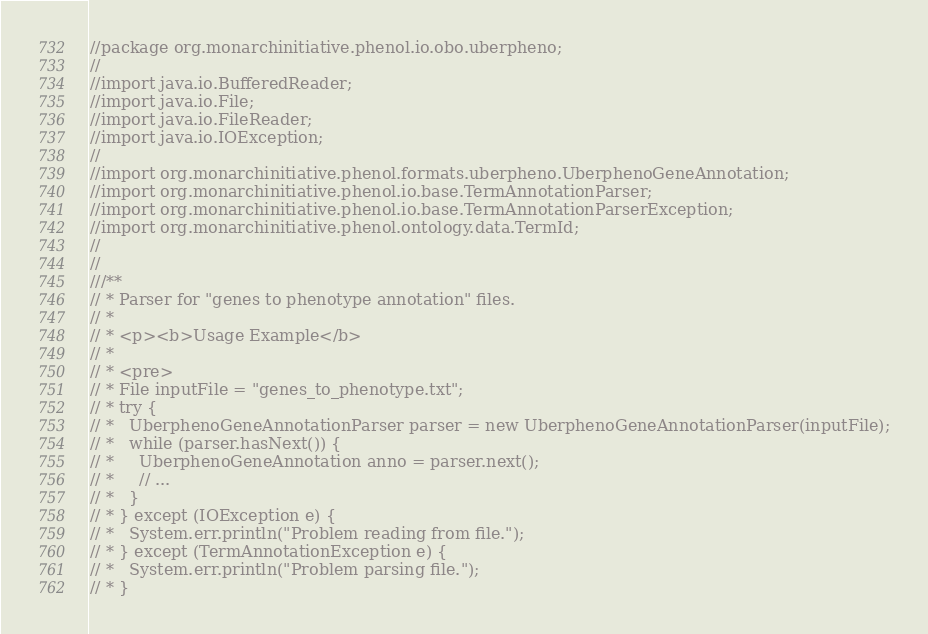<code> <loc_0><loc_0><loc_500><loc_500><_Java_>//package org.monarchinitiative.phenol.io.obo.uberpheno;
//
//import java.io.BufferedReader;
//import java.io.File;
//import java.io.FileReader;
//import java.io.IOException;
//
//import org.monarchinitiative.phenol.formats.uberpheno.UberphenoGeneAnnotation;
//import org.monarchinitiative.phenol.io.base.TermAnnotationParser;
//import org.monarchinitiative.phenol.io.base.TermAnnotationParserException;
//import org.monarchinitiative.phenol.ontology.data.TermId;
//
//
///**
// * Parser for "genes to phenotype annotation" files.
// *
// * <p><b>Usage Example</b>
// *
// * <pre>
// * File inputFile = "genes_to_phenotype.txt";
// * try {
// *   UberphenoGeneAnnotationParser parser = new UberphenoGeneAnnotationParser(inputFile);
// *   while (parser.hasNext()) {
// *     UberphenoGeneAnnotation anno = parser.next();
// *     // ...
// *   }
// * } except (IOException e) {
// *   System.err.println("Problem reading from file.");
// * } except (TermAnnotationException e) {
// *   System.err.println("Problem parsing file.");
// * }</code> 